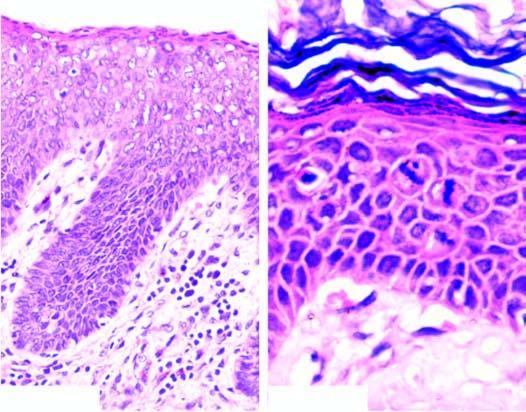what shows mitotic figures in the layers of squamous epithelium?
Answer the question using a single word or phrase. Photomicrograph on right under higher magnification 